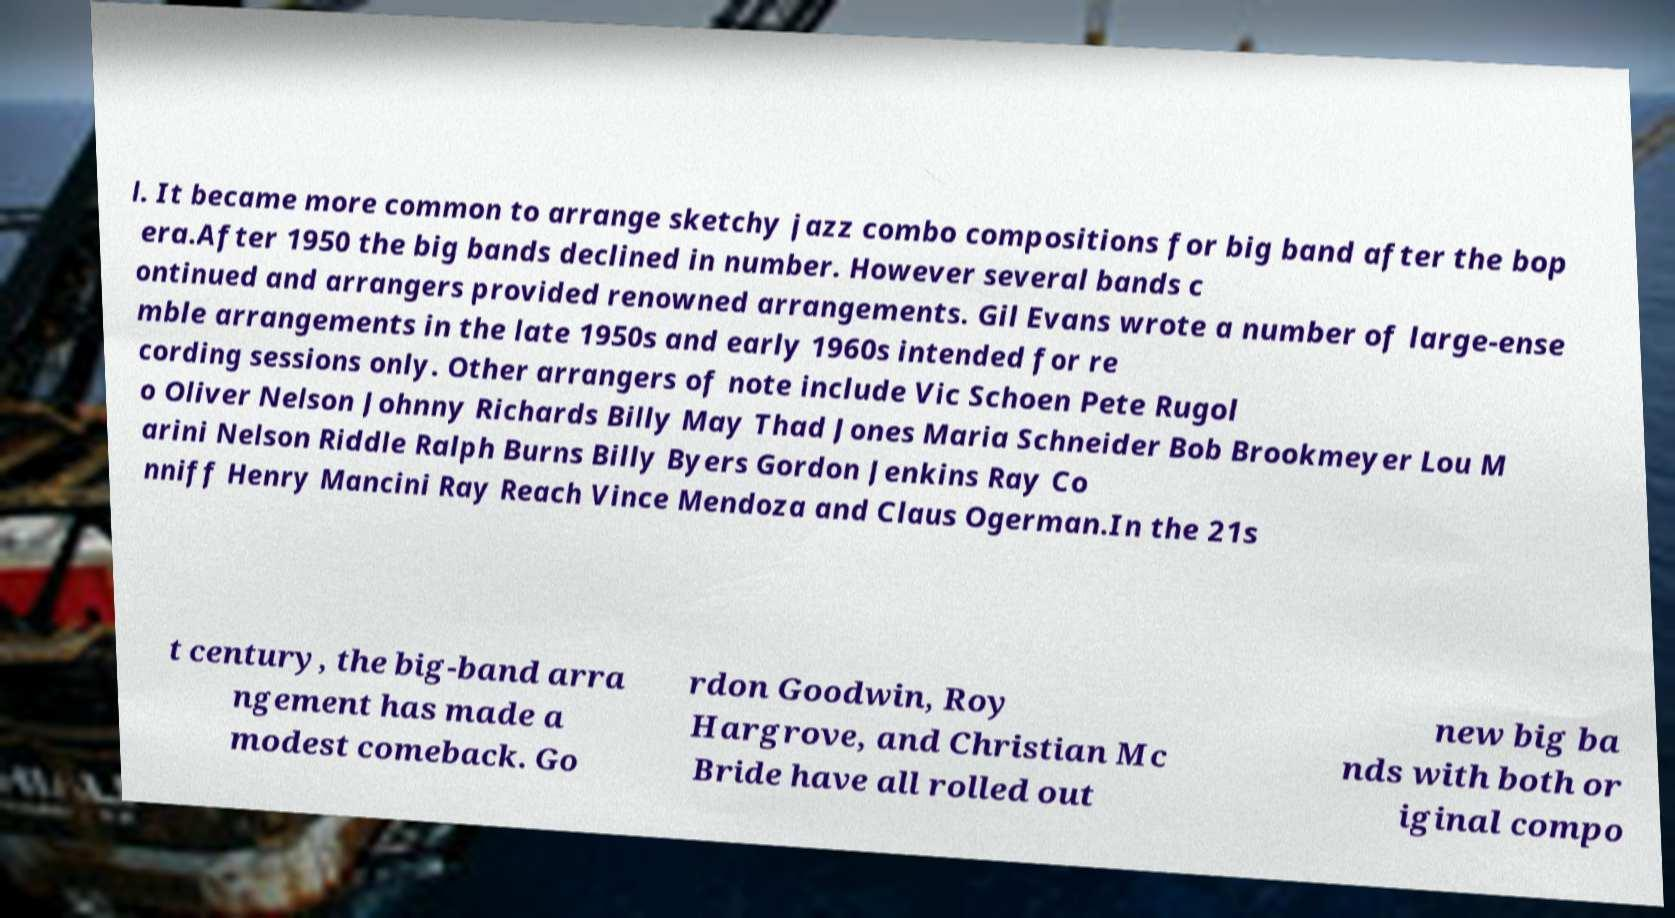I need the written content from this picture converted into text. Can you do that? l. It became more common to arrange sketchy jazz combo compositions for big band after the bop era.After 1950 the big bands declined in number. However several bands c ontinued and arrangers provided renowned arrangements. Gil Evans wrote a number of large-ense mble arrangements in the late 1950s and early 1960s intended for re cording sessions only. Other arrangers of note include Vic Schoen Pete Rugol o Oliver Nelson Johnny Richards Billy May Thad Jones Maria Schneider Bob Brookmeyer Lou M arini Nelson Riddle Ralph Burns Billy Byers Gordon Jenkins Ray Co nniff Henry Mancini Ray Reach Vince Mendoza and Claus Ogerman.In the 21s t century, the big-band arra ngement has made a modest comeback. Go rdon Goodwin, Roy Hargrove, and Christian Mc Bride have all rolled out new big ba nds with both or iginal compo 